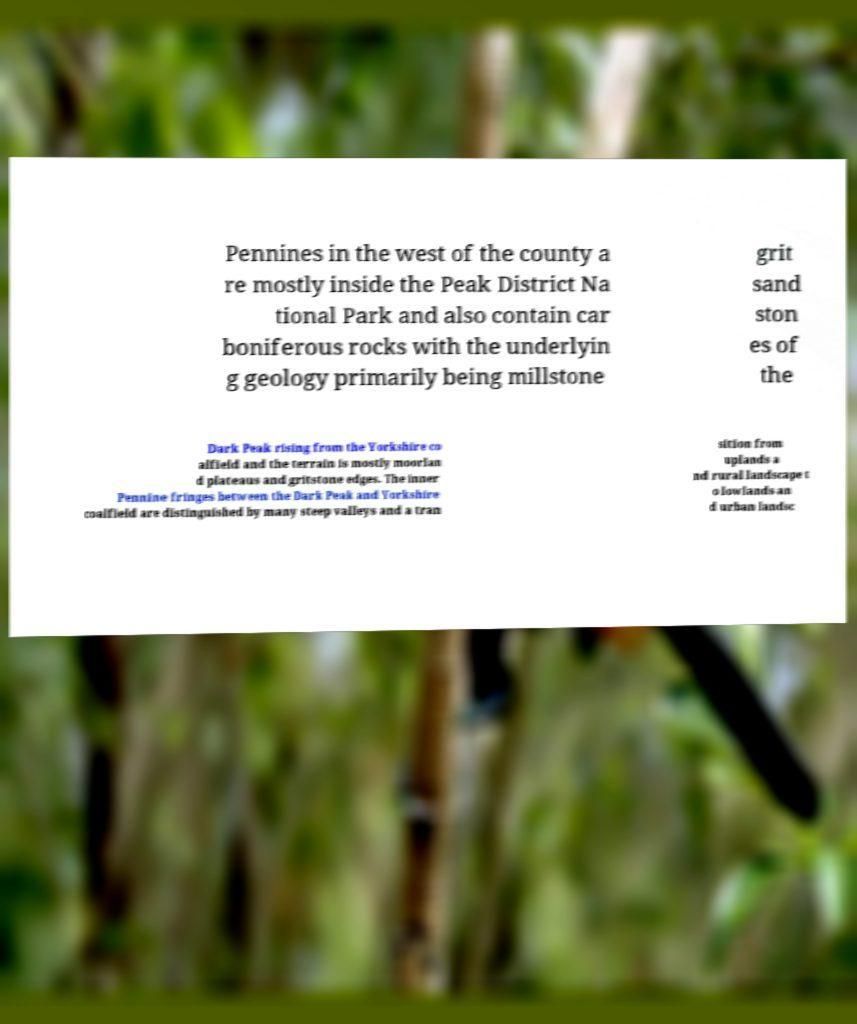Please read and relay the text visible in this image. What does it say? Pennines in the west of the county a re mostly inside the Peak District Na tional Park and also contain car boniferous rocks with the underlyin g geology primarily being millstone grit sand ston es of the Dark Peak rising from the Yorkshire co alfield and the terrain is mostly moorlan d plateaus and gritstone edges. The inner Pennine fringes between the Dark Peak and Yorkshire coalfield are distinguished by many steep valleys and a tran sition from uplands a nd rural landscape t o lowlands an d urban landsc 